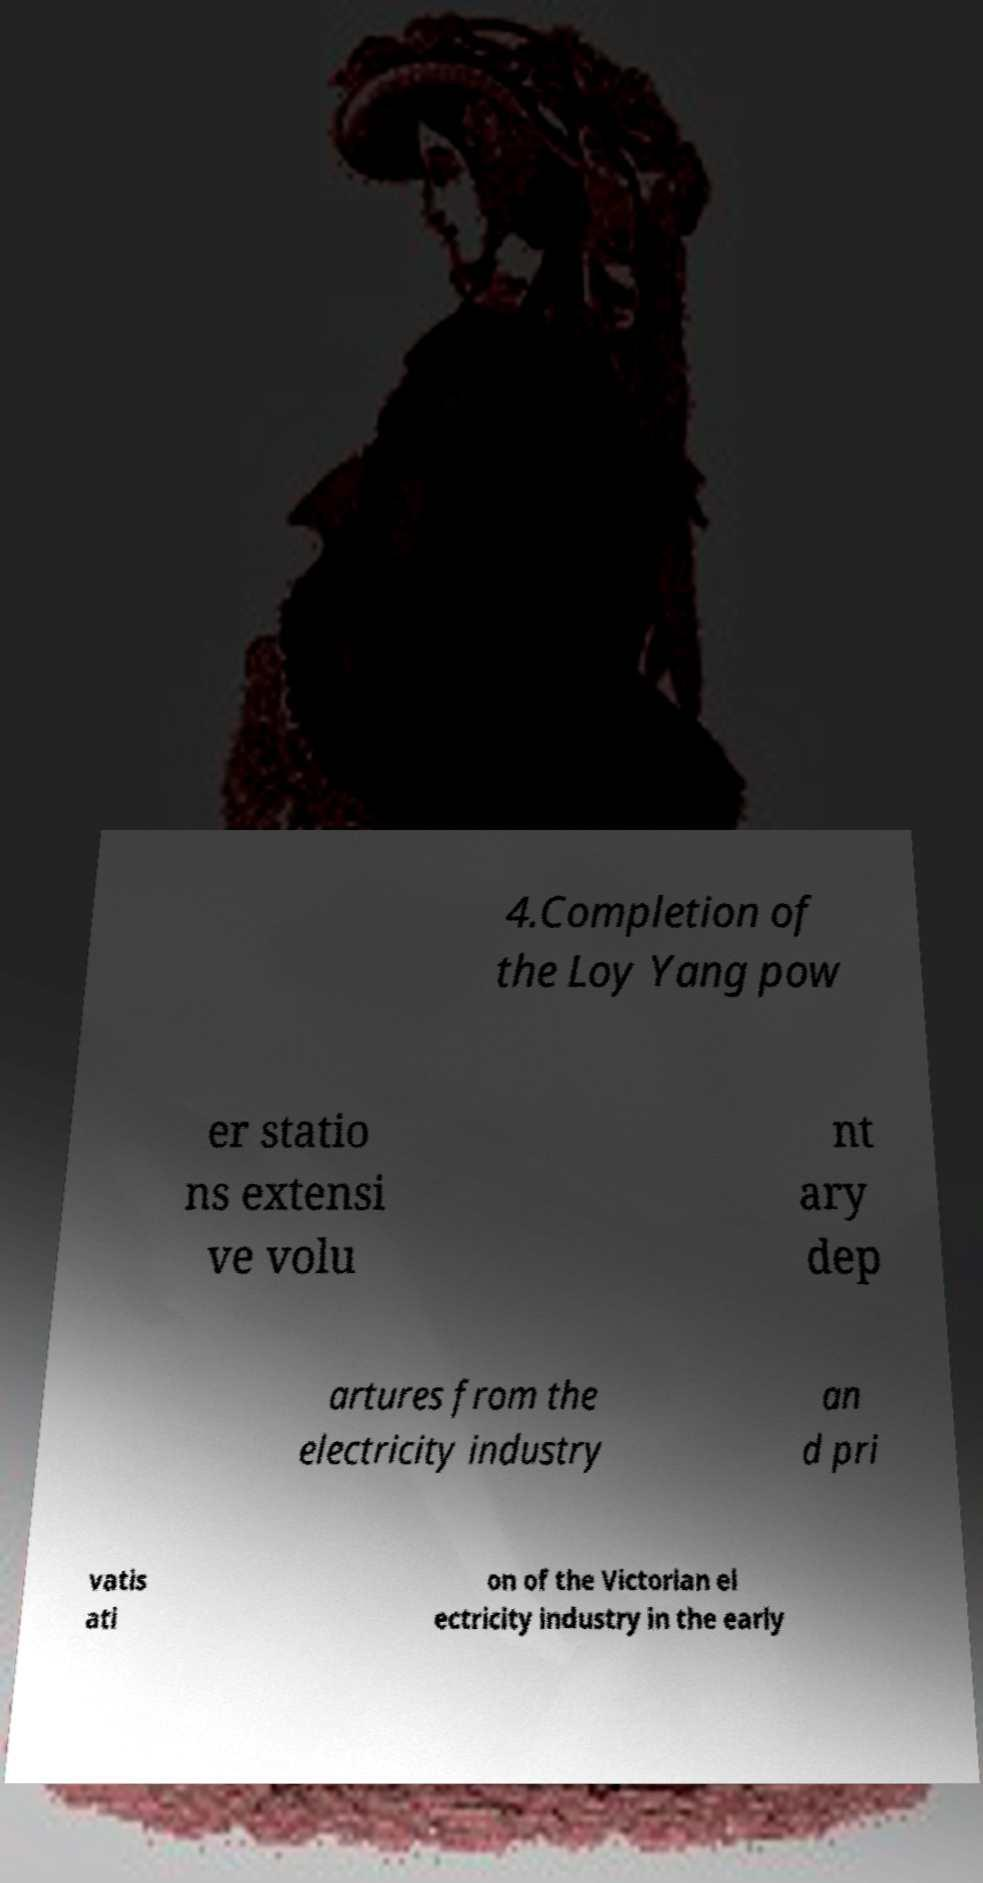Can you accurately transcribe the text from the provided image for me? 4.Completion of the Loy Yang pow er statio ns extensi ve volu nt ary dep artures from the electricity industry an d pri vatis ati on of the Victorian el ectricity industry in the early 